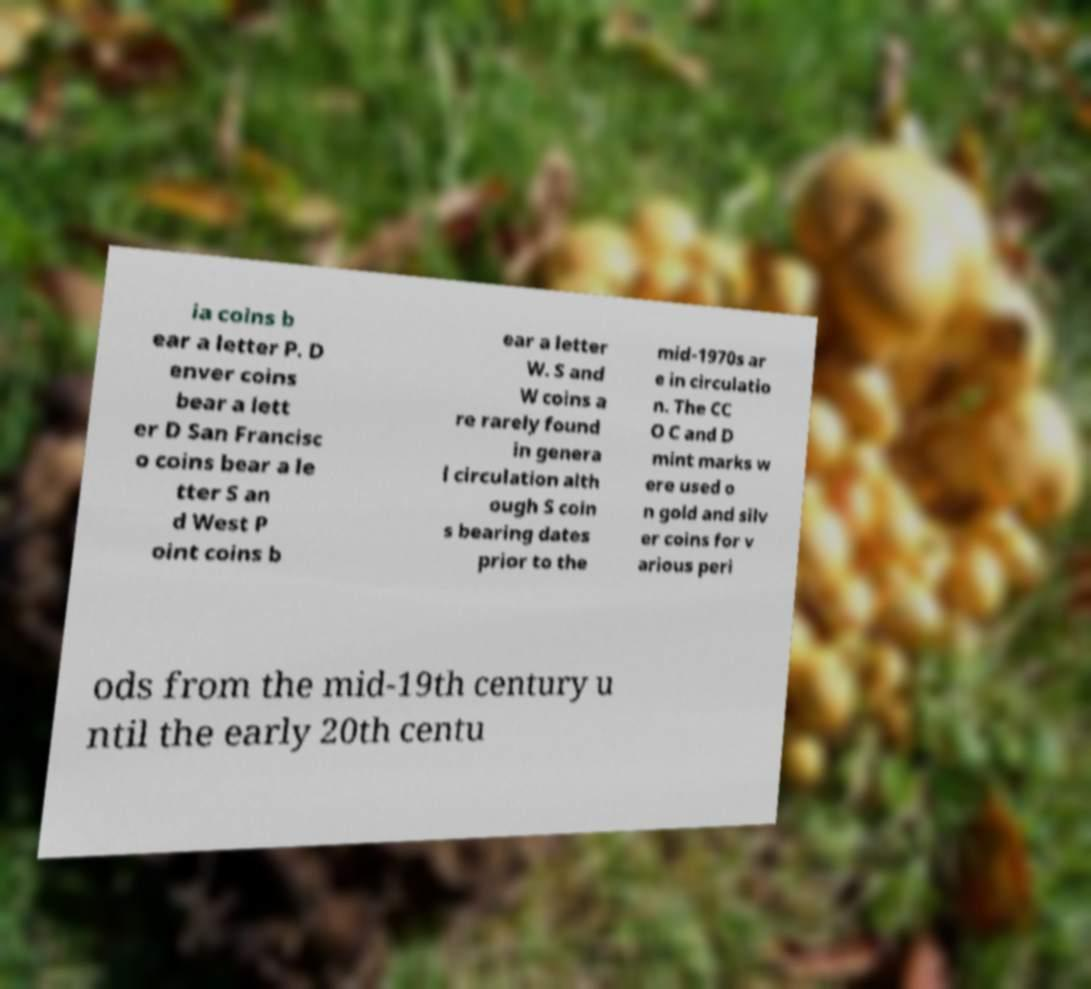Can you accurately transcribe the text from the provided image for me? ia coins b ear a letter P. D enver coins bear a lett er D San Francisc o coins bear a le tter S an d West P oint coins b ear a letter W. S and W coins a re rarely found in genera l circulation alth ough S coin s bearing dates prior to the mid-1970s ar e in circulatio n. The CC O C and D mint marks w ere used o n gold and silv er coins for v arious peri ods from the mid-19th century u ntil the early 20th centu 